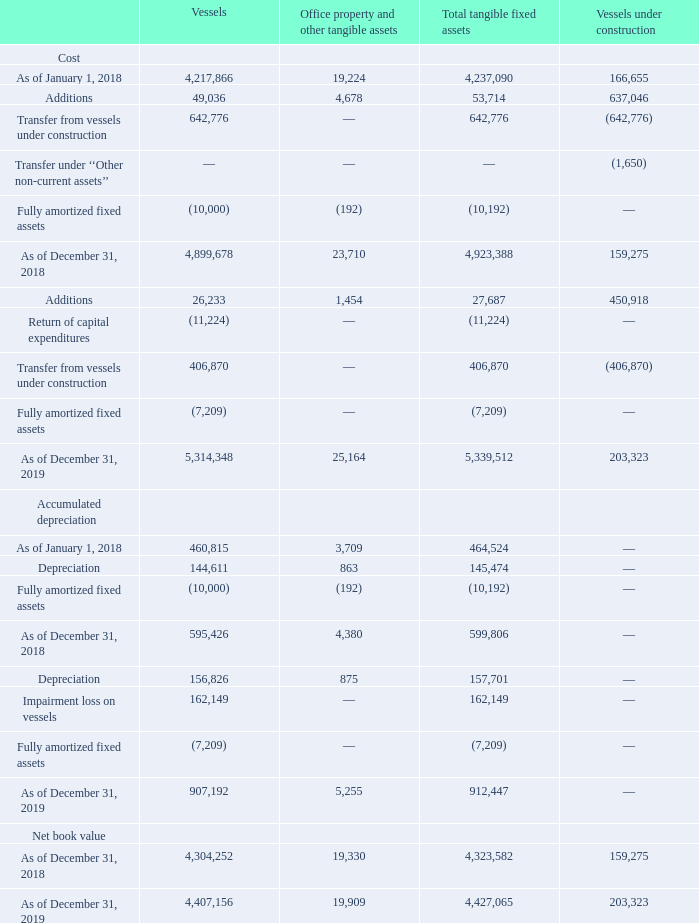GasLog Ltd. and its Subsidiaries Notes to the consolidated financial statements (Continued) For the years ended December 31, 2017, 2018 and 2019 (All amounts expressed in thousands of U.S. Dollars, except share and per share data)    6. Tangible Fixed Assets and Vessels Under Construction
The movements in tangible fixed assets and vessels under construction are reported in the following table:
Vessels with an aggregate carrying amount of $4,407,156 as of December 31, 2019 (December 31, 2018: $4,304,252) have been pledged as collateral under the terms of the Group’s loan agreements (Note 13).
As of December 31, 2019, a number of increasingly strong negative indicators such as the difference between ship broker estimates of the fair market values and the carrying values of the Group’s Steam vessels, the lack of liquidity in the market for term employment for Steam vessels and reduced expectations for the estimated rates at which such term employment could be secured, together with the continued addition of modern, larger and more fuel efficient LNG carriers to the global fleet, prompted the Group to perform an impairment assessment of its vessels in accordance with the
In which years was the movements in tangible fixed assets and vessels under construction recorded for? 2018, 2019. Why did the Group perform impairment assessment of its vessels? Increasingly strong negative indicators such as the difference between ship broker estimates of the fair market values and the carrying values of the group’s steam vessels, the lack of liquidity in the market for term employment for steam vessels and reduced expectations for the estimated rates at which such term employment could be secured, together with the continued addition of modern, larger and more fuel efficient lng carriers to the global fleet. What was the aggregate carrying amount of the vessels in 2018?
Answer scale should be: thousand. $4,304,252. In which end year has a higher vessel accumulated depreciation? 907,192 > 595,426
Answer: 2019. What was the change in vessel cost from end 2018 to end 2019? 5,314,348 - 4,899,678 
Answer: 414670. What was the percentage change in vessel net book value end 2018 to end 2019?
Answer scale should be: percent. (4,407,156 - 4,304,252)/4,304,252 
Answer: 2.39. 